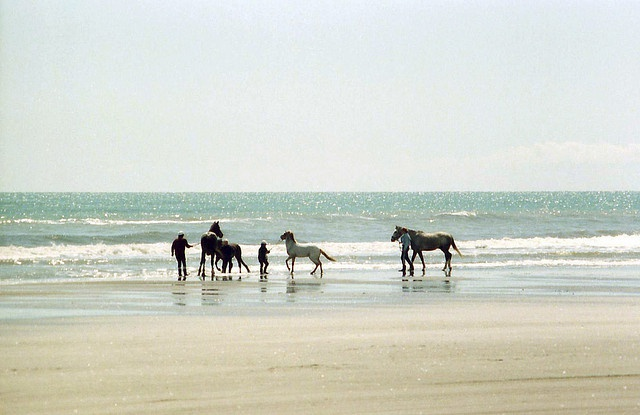Describe the objects in this image and their specific colors. I can see horse in lightgray, gray, black, ivory, and darkgreen tones, horse in lightgray, black, gray, and ivory tones, horse in lightgray, black, gray, darkgreen, and darkgray tones, horse in lightgray, black, gray, darkgreen, and maroon tones, and people in lightgray, black, darkgray, gray, and darkgreen tones in this image. 